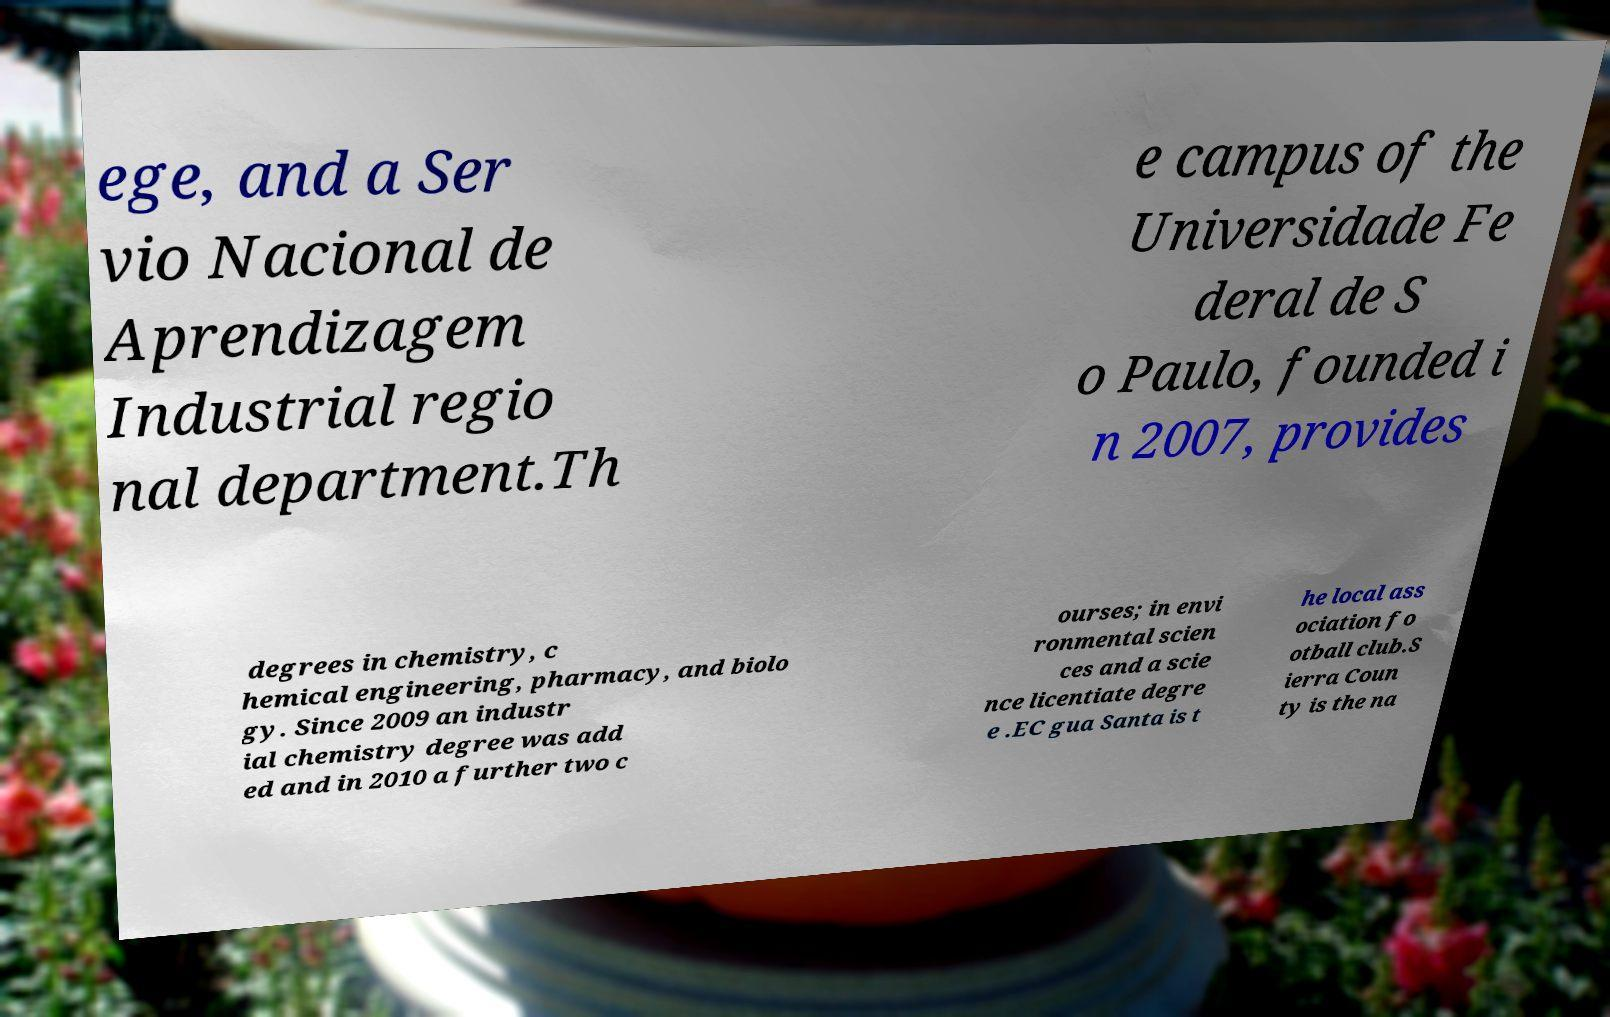Can you accurately transcribe the text from the provided image for me? ege, and a Ser vio Nacional de Aprendizagem Industrial regio nal department.Th e campus of the Universidade Fe deral de S o Paulo, founded i n 2007, provides degrees in chemistry, c hemical engineering, pharmacy, and biolo gy. Since 2009 an industr ial chemistry degree was add ed and in 2010 a further two c ourses; in envi ronmental scien ces and a scie nce licentiate degre e .EC gua Santa is t he local ass ociation fo otball club.S ierra Coun ty is the na 